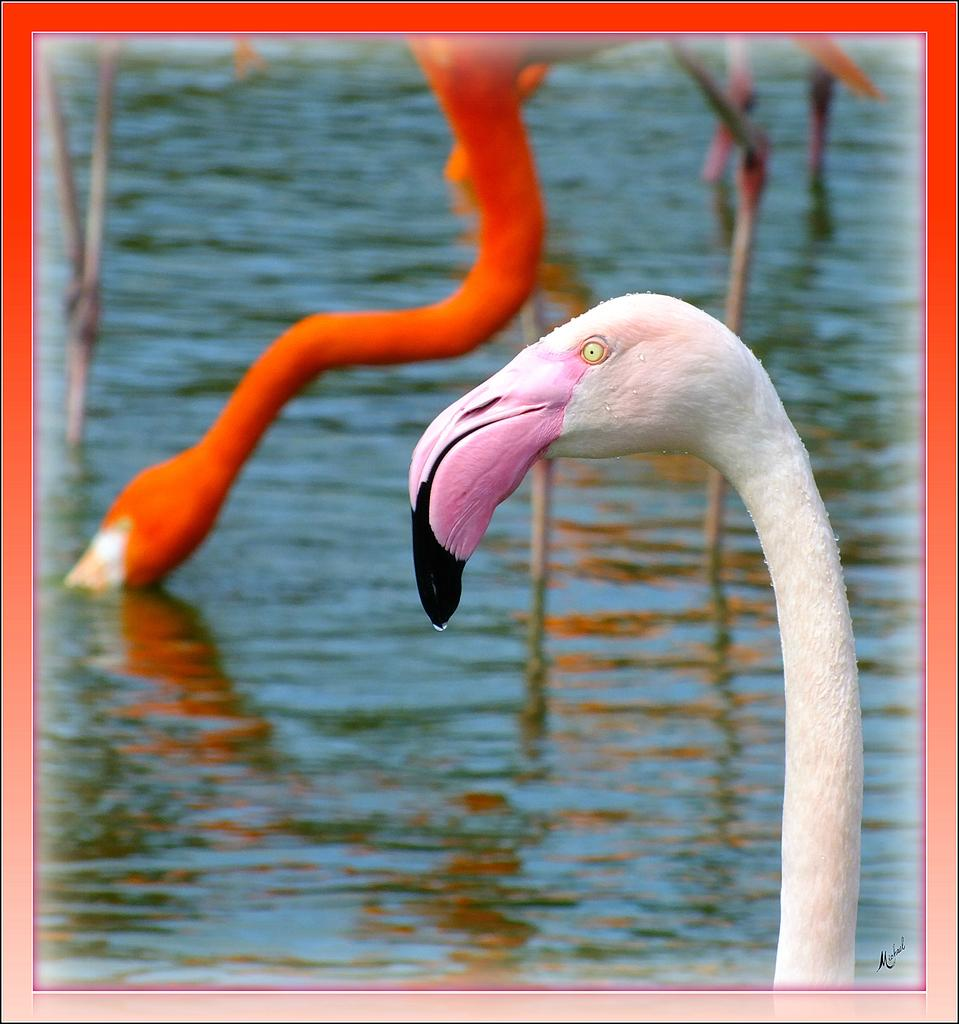What type of animals can be seen in the image? There are birds in the image. Can you describe the location of some of the birds in the image? Some of the birds are at the bottom of the image. What is the appearance of one of the birds in the image? There is a white-colored bird with a pink beak in the image. What type of cork can be seen on the wrist of the bird in the image? There is no cork or wrist visible on the bird in the image; it is a bird with a beak and feathers. Is there a basketball being played by the birds in the image? There is no basketball present in the image; it features birds in their natural environment. 